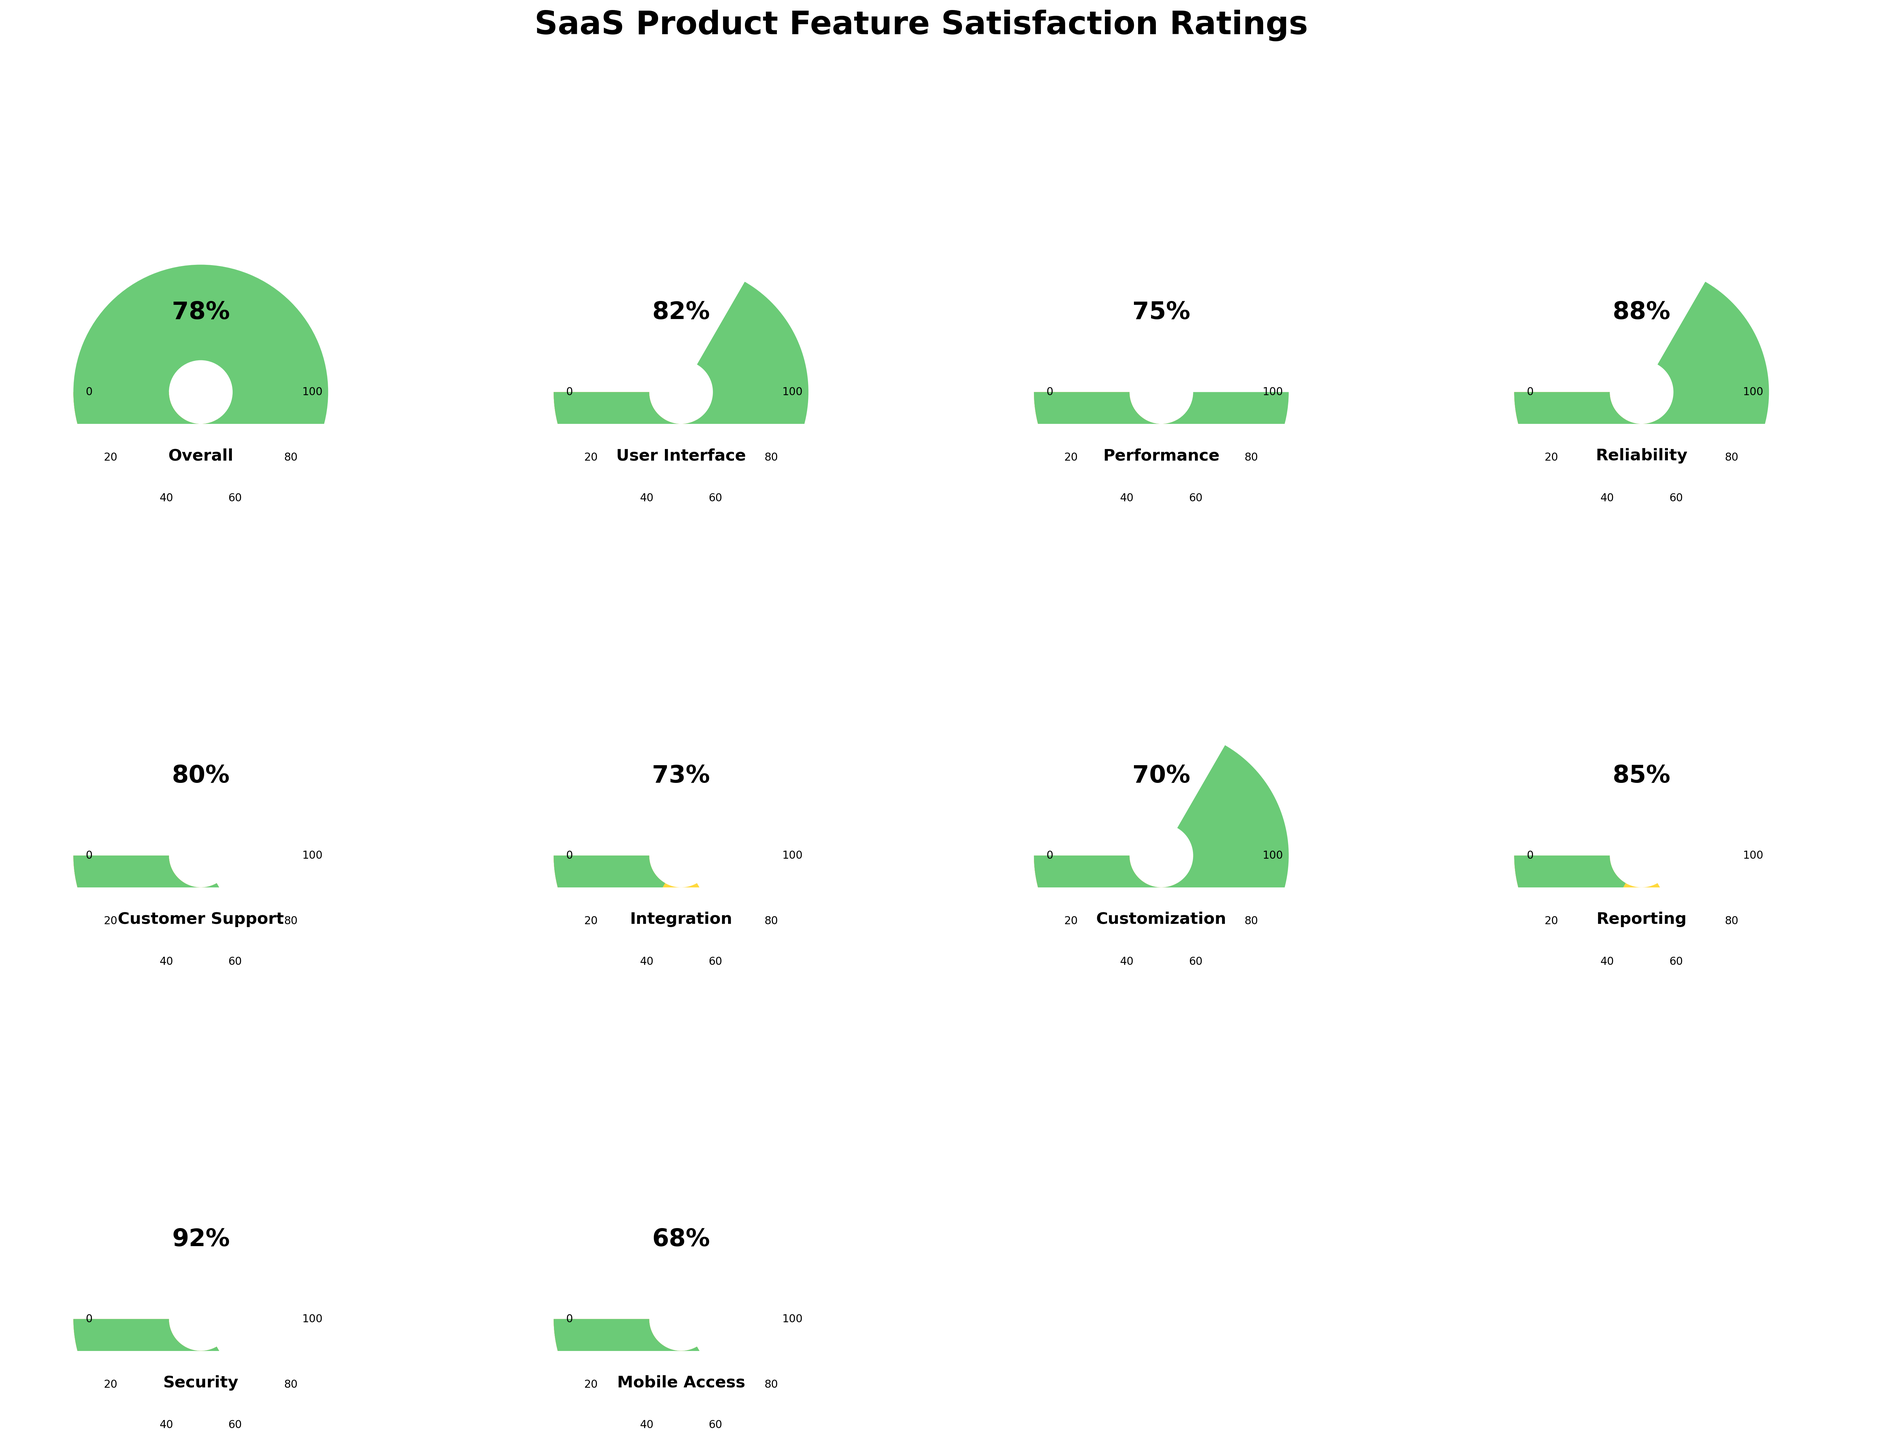Which feature has the highest satisfaction rating? By looking at the plot, the feature with the highest satisfaction rating is identified by the gauge that has the needle furthest to the right. The Security feature has the highest rating.
Answer: Security What is the satisfaction rating for the User Interface? Locate the gauge chart labeled "User Interface" and read the value indicated at the needle's position. The satisfaction rating is 82.
Answer: 82 Which features have a satisfaction rating below 75? Identify the gauges where the needle points below 75. The features with ratings below 75 are Integration, Customization, and Mobile Access.
Answer: Integration, Customization, Mobile Access Compare the satisfaction ratings for Performance and Customer Support. Which is higher? Locate the gauges for Performance and Customer Support. Compare the needle positions: Performance is at 75, and Customer Support is at 80. Customer Support is higher.
Answer: Customer Support What is the average satisfaction rating across all features? Sum all the satisfaction ratings: 78 (Overall) + 82 (User Interface) + 75 (Performance) + 88 (Reliability) + 80 (Customer Support) + 73 (Integration) + 70 (Customization) + 85 (Reporting) + 92 (Security) + 68 (Mobile Access) = 791. Divide the sum by the number of features (10): 791/10 = 79.1.
Answer: 79.1 Which feature has the closest satisfaction rating to 80? Locate the gauges that have values around 80. Customer Support has a satisfaction rating of 80.
Answer: Customer Support How many features have a satisfaction rating above 80? Count the gauges where the needle points above 80. User Interface, Reliability, Reporting, and Security have ratings above 80. That totals to 4 features.
Answer: 4 What's the difference in satisfaction ratings between Integration and Reporting? Locate the ratings for Integration (73) and Reporting (85). Subtract the smaller rating from the larger one: 85 - 73 = 12.
Answer: 12 Which feature has a satisfaction rating exactly within the middle of the range, averaging the highest and lowest feature ratings? The highest rating is for Security (92), and the lowest is for Mobile Access (68). The middle value, or mid-point, between these two is (92 + 68) / 2 = 80. The feature with an exact rating of 80 is Customer Support.
Answer: Customer Support Is the satisfaction rating for Overall higher or lower than the average satisfaction rating? First, find the average rating (79.1) as calculated before. Then compare it to the Overall rating (78). The Overall rating is lower than the average.
Answer: Lower 